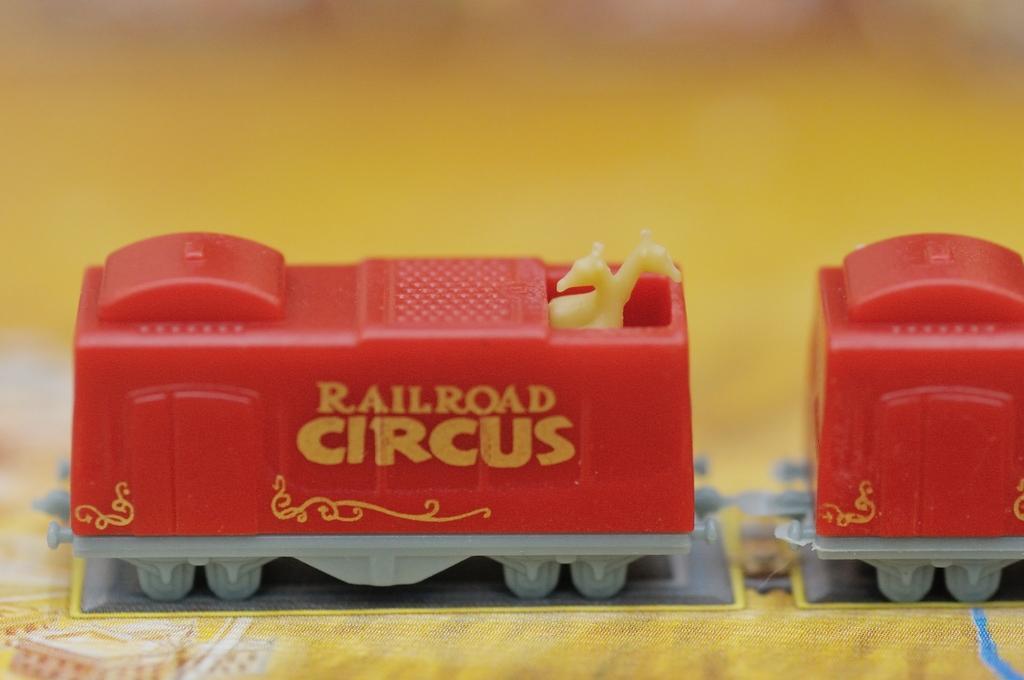Can you describe this image briefly? In this image we can see legos. At the bottom there is a cloth. 